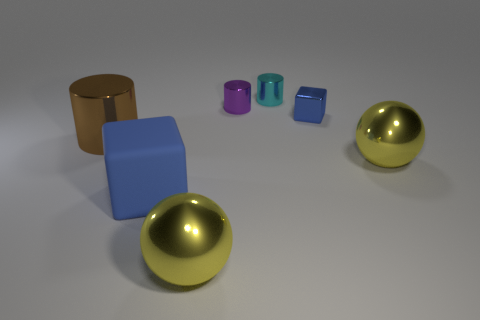How many objects are there, and what colors do they feature? In the image, there are a total of seven objects. Starting from the left, there's a brown cylinder, a blue cube, a purple cylinder, a teal cube, a green cube, and two golden spheres. 